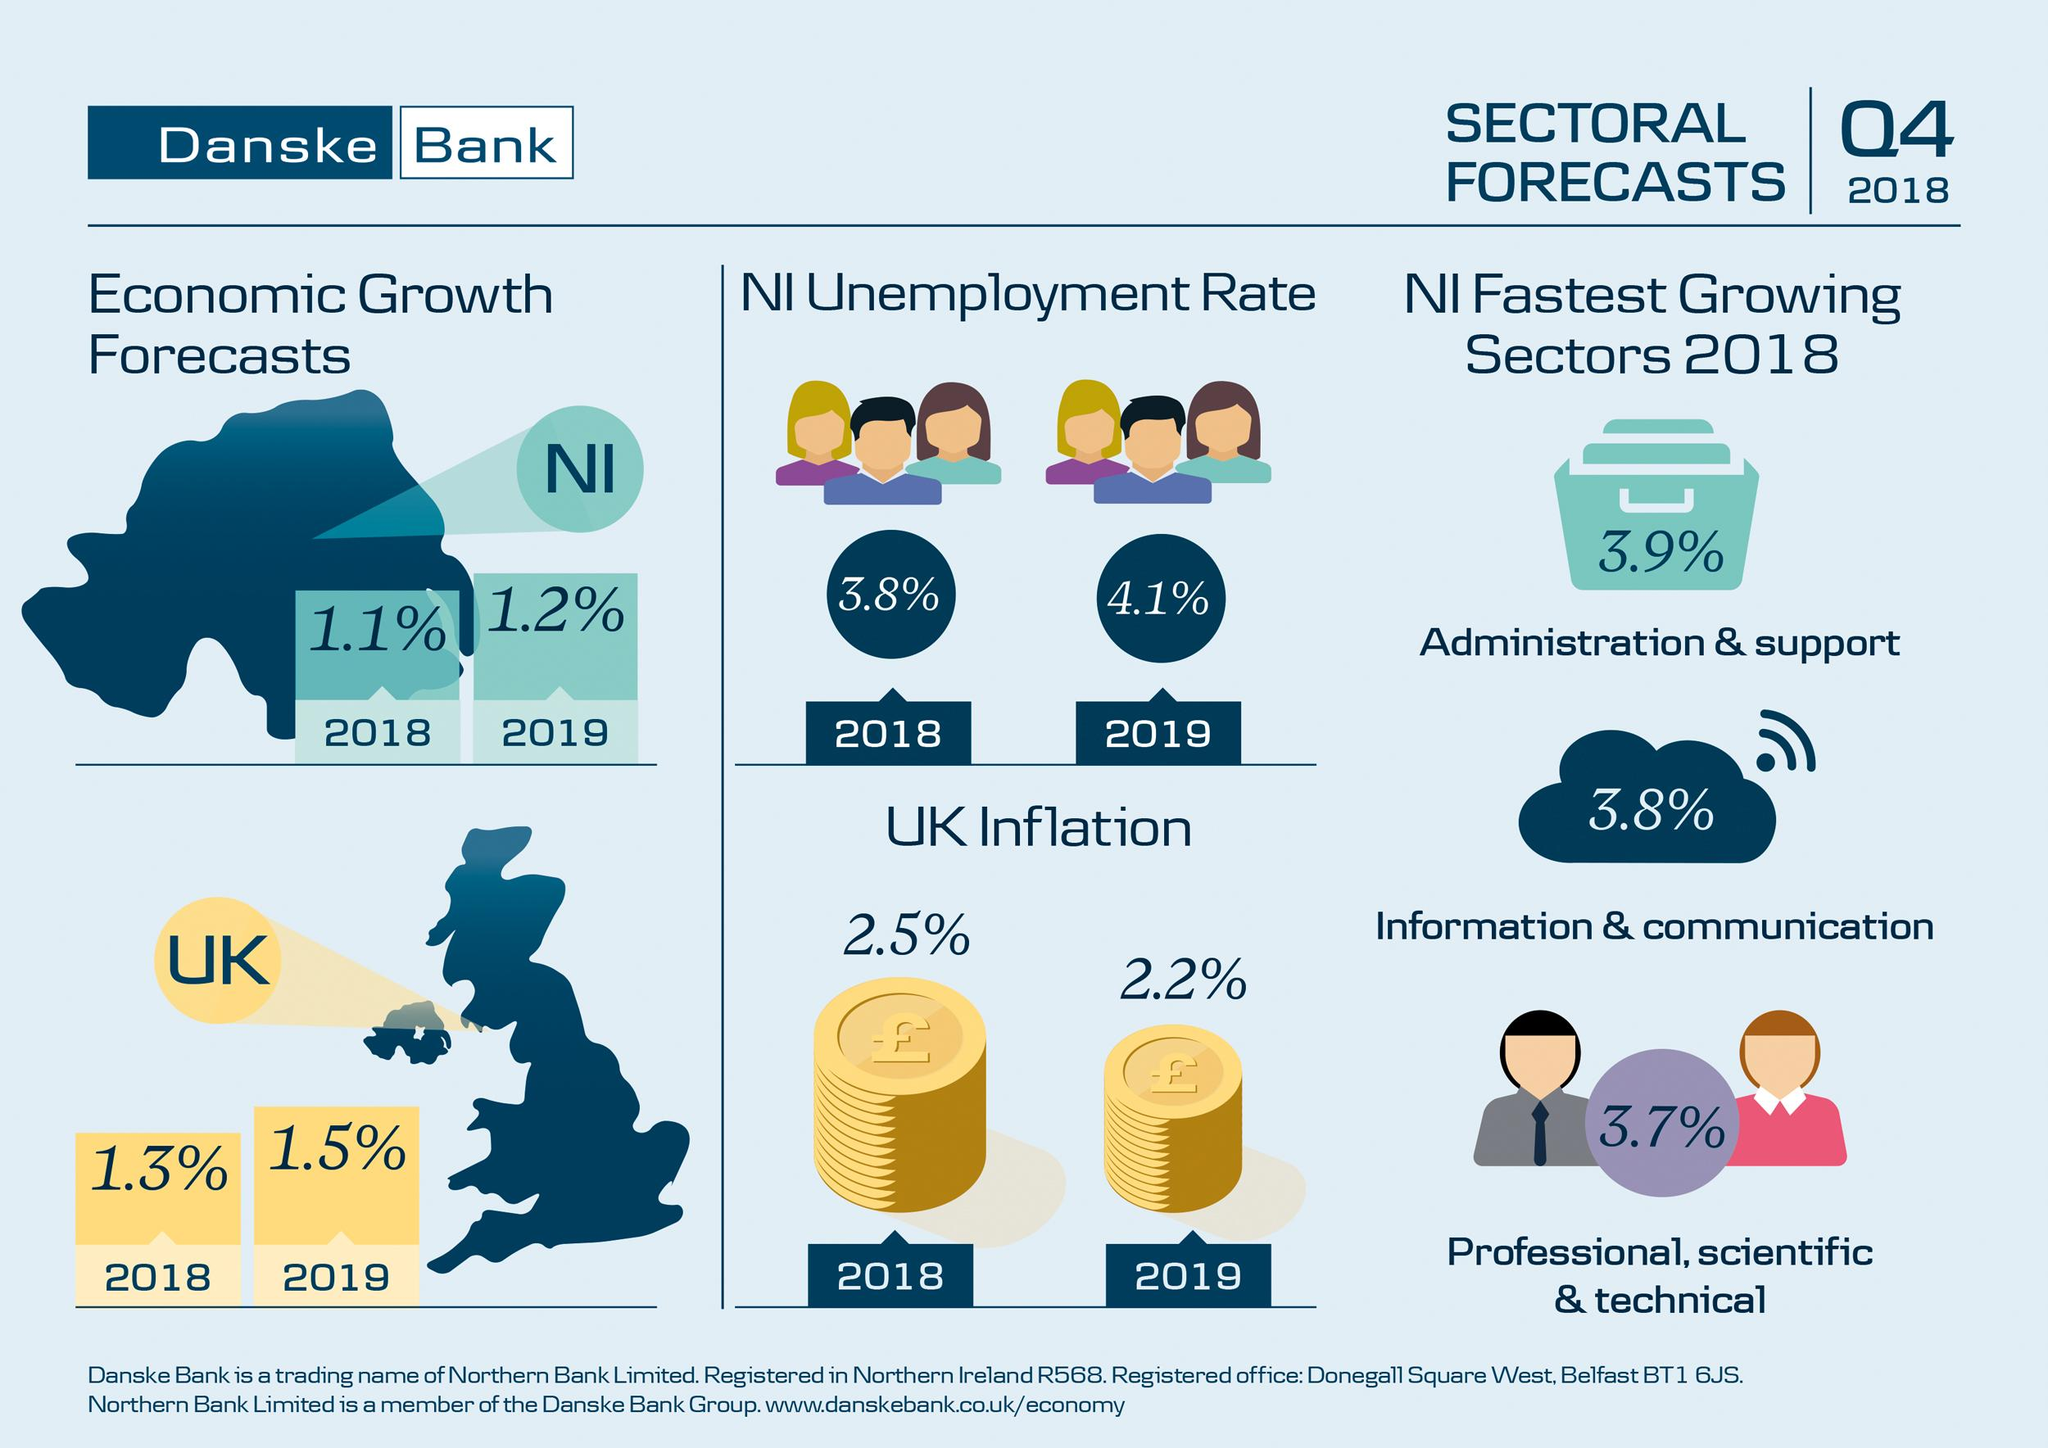Specify some key components in this picture. The economic growth rate of Northern Ireland in 2018 was 1.1%. In 2018, the Information & Communications sector in Northern Ireland demonstrated a growth rate of 3.8%. In 2018, the inflation rate in the United Kingdom was 2.5%. The estimated economic growth rate of the United Kingdom in 2019 is 1.5%. In 2019, the estimated unemployment rate in Northern Ireland was 4.1%. 